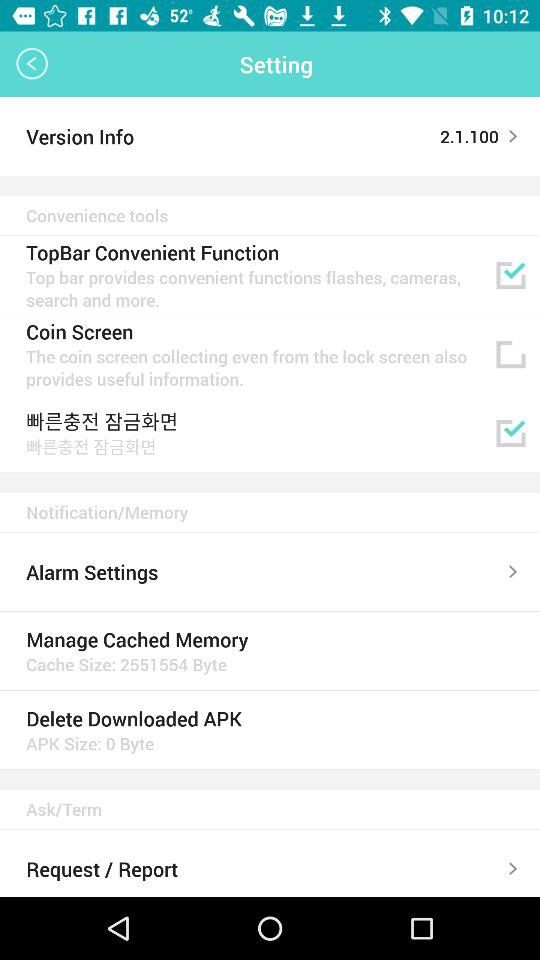What is the version? The version is 2.1.100. 